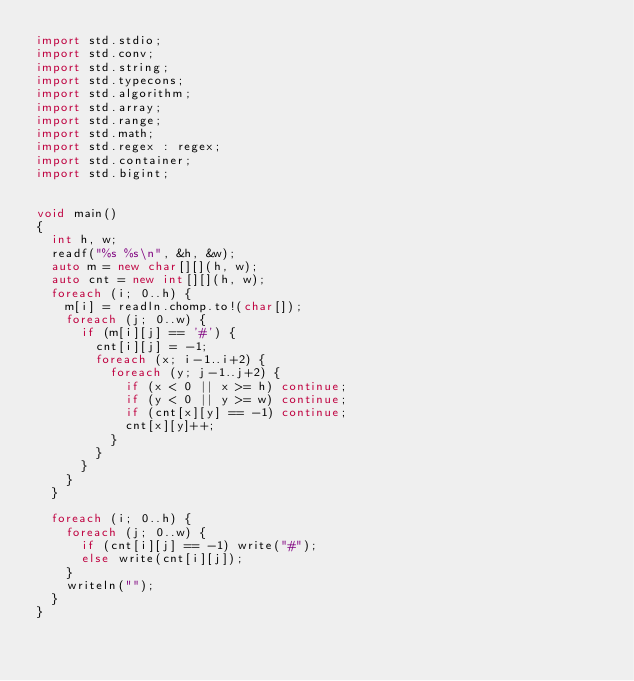Convert code to text. <code><loc_0><loc_0><loc_500><loc_500><_D_>import std.stdio;
import std.conv;
import std.string;
import std.typecons;
import std.algorithm;
import std.array;
import std.range;
import std.math;
import std.regex : regex;
import std.container;
import std.bigint;


void main()
{
  int h, w;
  readf("%s %s\n", &h, &w);
  auto m = new char[][](h, w);
  auto cnt = new int[][](h, w);
  foreach (i; 0..h) {
    m[i] = readln.chomp.to!(char[]);
    foreach (j; 0..w) {
      if (m[i][j] == '#') {
        cnt[i][j] = -1;
        foreach (x; i-1..i+2) {
          foreach (y; j-1..j+2) {
            if (x < 0 || x >= h) continue;
            if (y < 0 || y >= w) continue;
            if (cnt[x][y] == -1) continue;
            cnt[x][y]++;
          }
        }
      }
    }
  }

  foreach (i; 0..h) {
    foreach (j; 0..w) {
      if (cnt[i][j] == -1) write("#");
      else write(cnt[i][j]);
    }
    writeln("");
  }
}
</code> 